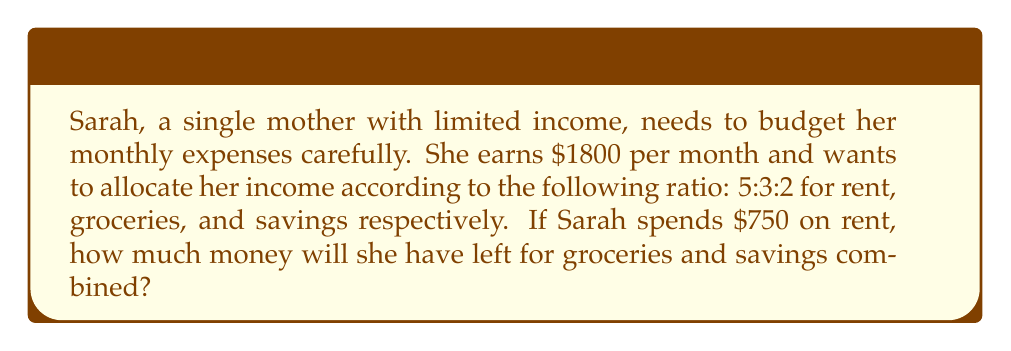Could you help me with this problem? Let's approach this problem step-by-step using ratios and proportions:

1) First, we need to understand the given ratio:
   5:3:2 for rent : groceries : savings

2) The total parts in this ratio is 5 + 3 + 2 = 10

3) We know that rent corresponds to 5 parts and is $750. Let's set up a proportion:
   
   $\frac{5}{10} = \frac{750}{x}$, where $x$ is the total budget

4) Cross multiply:
   $5x = 750 \cdot 10$
   $5x = 7500$

5) Solve for $x$:
   $x = \frac{7500}{5} = 1500$

6) So, the total amount Sarah should be allocating according to this ratio is $1500

7) To find how much is left for groceries and savings:
   $1800 - 750 = 1050$

Therefore, Sarah will have $1050 left for groceries and savings combined.

Note: The difference between Sarah's income ($1800) and the amount allocated by the ratio ($1500) could be used for other expenses or added to savings.
Answer: $1050 